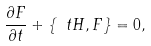Convert formula to latex. <formula><loc_0><loc_0><loc_500><loc_500>\frac { \partial F } { \partial t } + \{ \ t H , F \} = 0 ,</formula> 